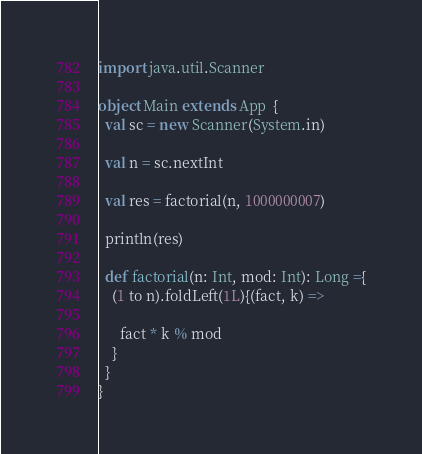Convert code to text. <code><loc_0><loc_0><loc_500><loc_500><_Scala_>import java.util.Scanner

object Main extends App  {
  val sc = new Scanner(System.in)

  val n = sc.nextInt

  val res = factorial(n, 1000000007)

  println(res)

  def factorial(n: Int, mod: Int): Long ={
    (1 to n).foldLeft(1L){(fact, k) =>

      fact * k % mod
    }
  }
}
</code> 